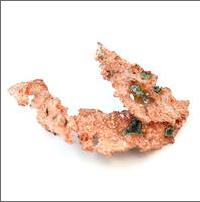What is the significance of the green patches seen on this sample of native copper? The green patches you see on native copper are likely caused by oxidation and exposure to moisture, leading to the formation of copper carbonate minerals such as malachite. This process, known as patination, not only provides an aesthetic variation but also offers insights into the copper's environmental exposure and aging process. 